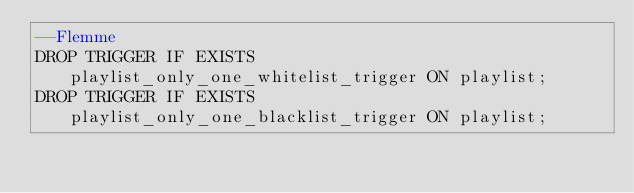<code> <loc_0><loc_0><loc_500><loc_500><_SQL_>--Flemme
DROP TRIGGER IF EXISTS playlist_only_one_whitelist_trigger ON playlist;
DROP TRIGGER IF EXISTS playlist_only_one_blacklist_trigger ON playlist;</code> 